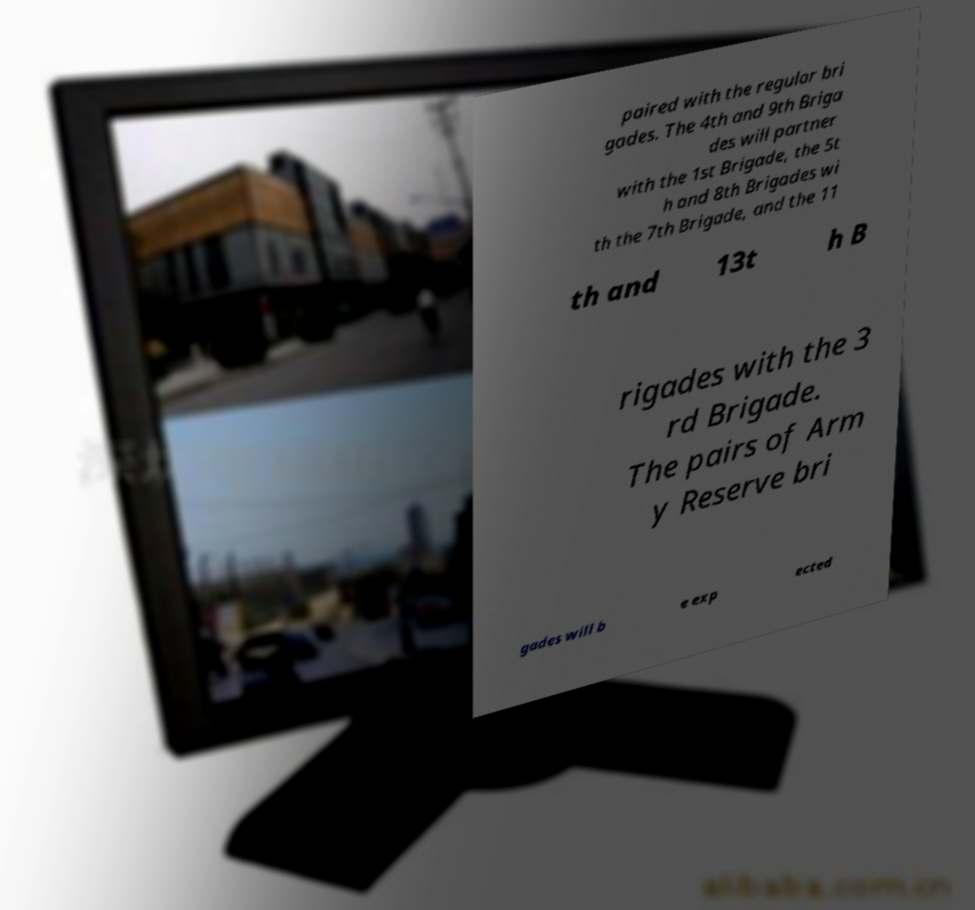Please identify and transcribe the text found in this image. paired with the regular bri gades. The 4th and 9th Briga des will partner with the 1st Brigade, the 5t h and 8th Brigades wi th the 7th Brigade, and the 11 th and 13t h B rigades with the 3 rd Brigade. The pairs of Arm y Reserve bri gades will b e exp ected 